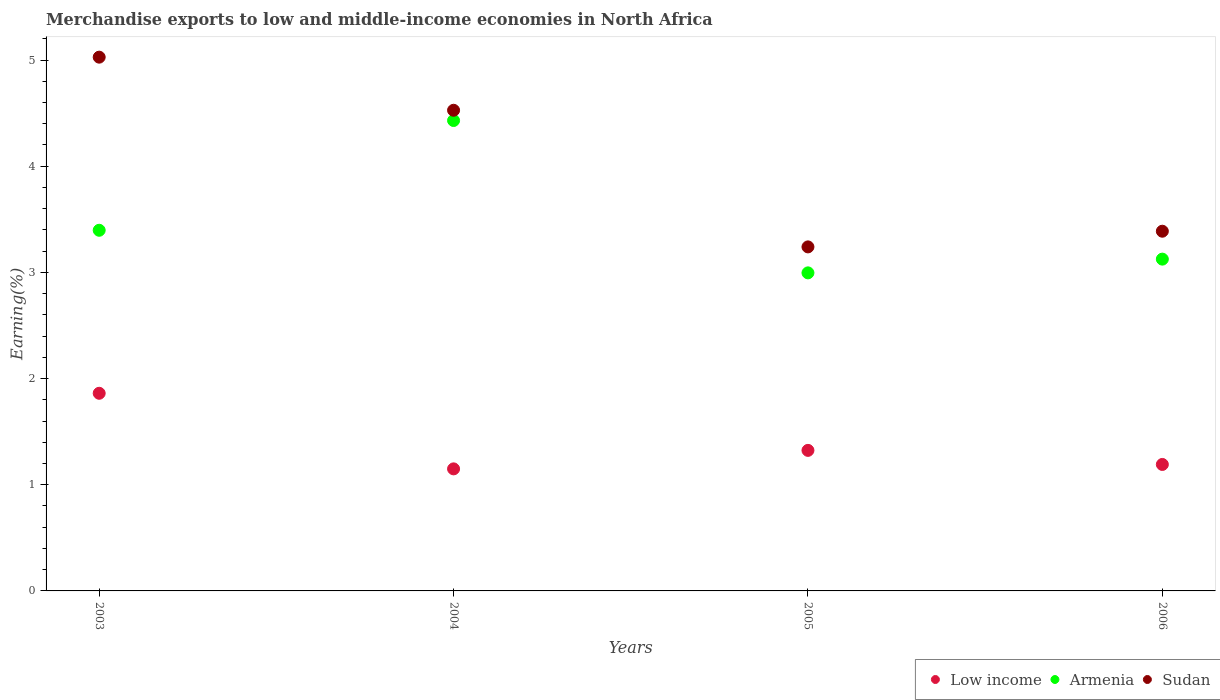Is the number of dotlines equal to the number of legend labels?
Provide a short and direct response. Yes. What is the percentage of amount earned from merchandise exports in Armenia in 2006?
Your answer should be very brief. 3.12. Across all years, what is the maximum percentage of amount earned from merchandise exports in Sudan?
Give a very brief answer. 5.03. Across all years, what is the minimum percentage of amount earned from merchandise exports in Low income?
Keep it short and to the point. 1.15. In which year was the percentage of amount earned from merchandise exports in Sudan maximum?
Offer a very short reply. 2003. In which year was the percentage of amount earned from merchandise exports in Sudan minimum?
Your answer should be compact. 2005. What is the total percentage of amount earned from merchandise exports in Low income in the graph?
Offer a very short reply. 5.53. What is the difference between the percentage of amount earned from merchandise exports in Sudan in 2003 and that in 2005?
Provide a short and direct response. 1.79. What is the difference between the percentage of amount earned from merchandise exports in Sudan in 2006 and the percentage of amount earned from merchandise exports in Armenia in 2005?
Give a very brief answer. 0.39. What is the average percentage of amount earned from merchandise exports in Armenia per year?
Your response must be concise. 3.49. In the year 2003, what is the difference between the percentage of amount earned from merchandise exports in Armenia and percentage of amount earned from merchandise exports in Sudan?
Your answer should be compact. -1.63. In how many years, is the percentage of amount earned from merchandise exports in Low income greater than 3.2 %?
Your answer should be compact. 0. What is the ratio of the percentage of amount earned from merchandise exports in Sudan in 2005 to that in 2006?
Your answer should be compact. 0.96. Is the percentage of amount earned from merchandise exports in Sudan in 2003 less than that in 2006?
Make the answer very short. No. What is the difference between the highest and the second highest percentage of amount earned from merchandise exports in Armenia?
Your answer should be very brief. 1.03. What is the difference between the highest and the lowest percentage of amount earned from merchandise exports in Sudan?
Ensure brevity in your answer.  1.79. In how many years, is the percentage of amount earned from merchandise exports in Armenia greater than the average percentage of amount earned from merchandise exports in Armenia taken over all years?
Keep it short and to the point. 1. Is the sum of the percentage of amount earned from merchandise exports in Low income in 2004 and 2005 greater than the maximum percentage of amount earned from merchandise exports in Armenia across all years?
Your answer should be very brief. No. Is it the case that in every year, the sum of the percentage of amount earned from merchandise exports in Sudan and percentage of amount earned from merchandise exports in Armenia  is greater than the percentage of amount earned from merchandise exports in Low income?
Your response must be concise. Yes. Is the percentage of amount earned from merchandise exports in Low income strictly less than the percentage of amount earned from merchandise exports in Armenia over the years?
Give a very brief answer. Yes. How many dotlines are there?
Provide a short and direct response. 3. Are the values on the major ticks of Y-axis written in scientific E-notation?
Give a very brief answer. No. Does the graph contain grids?
Provide a short and direct response. No. How many legend labels are there?
Your answer should be compact. 3. How are the legend labels stacked?
Give a very brief answer. Horizontal. What is the title of the graph?
Make the answer very short. Merchandise exports to low and middle-income economies in North Africa. Does "Europe(all income levels)" appear as one of the legend labels in the graph?
Make the answer very short. No. What is the label or title of the X-axis?
Your response must be concise. Years. What is the label or title of the Y-axis?
Give a very brief answer. Earning(%). What is the Earning(%) in Low income in 2003?
Offer a very short reply. 1.86. What is the Earning(%) in Armenia in 2003?
Offer a very short reply. 3.4. What is the Earning(%) in Sudan in 2003?
Make the answer very short. 5.03. What is the Earning(%) in Low income in 2004?
Offer a very short reply. 1.15. What is the Earning(%) of Armenia in 2004?
Provide a short and direct response. 4.43. What is the Earning(%) of Sudan in 2004?
Your response must be concise. 4.53. What is the Earning(%) of Low income in 2005?
Give a very brief answer. 1.32. What is the Earning(%) of Armenia in 2005?
Give a very brief answer. 3. What is the Earning(%) of Sudan in 2005?
Make the answer very short. 3.24. What is the Earning(%) in Low income in 2006?
Your answer should be very brief. 1.19. What is the Earning(%) in Armenia in 2006?
Offer a very short reply. 3.12. What is the Earning(%) in Sudan in 2006?
Your response must be concise. 3.39. Across all years, what is the maximum Earning(%) of Low income?
Keep it short and to the point. 1.86. Across all years, what is the maximum Earning(%) of Armenia?
Ensure brevity in your answer.  4.43. Across all years, what is the maximum Earning(%) in Sudan?
Your response must be concise. 5.03. Across all years, what is the minimum Earning(%) of Low income?
Provide a short and direct response. 1.15. Across all years, what is the minimum Earning(%) of Armenia?
Your response must be concise. 3. Across all years, what is the minimum Earning(%) of Sudan?
Ensure brevity in your answer.  3.24. What is the total Earning(%) of Low income in the graph?
Offer a very short reply. 5.53. What is the total Earning(%) of Armenia in the graph?
Your response must be concise. 13.95. What is the total Earning(%) in Sudan in the graph?
Your answer should be very brief. 16.18. What is the difference between the Earning(%) of Low income in 2003 and that in 2004?
Your answer should be compact. 0.71. What is the difference between the Earning(%) of Armenia in 2003 and that in 2004?
Your response must be concise. -1.03. What is the difference between the Earning(%) in Sudan in 2003 and that in 2004?
Offer a terse response. 0.5. What is the difference between the Earning(%) in Low income in 2003 and that in 2005?
Provide a short and direct response. 0.54. What is the difference between the Earning(%) in Armenia in 2003 and that in 2005?
Keep it short and to the point. 0.4. What is the difference between the Earning(%) in Sudan in 2003 and that in 2005?
Give a very brief answer. 1.79. What is the difference between the Earning(%) in Low income in 2003 and that in 2006?
Offer a very short reply. 0.67. What is the difference between the Earning(%) of Armenia in 2003 and that in 2006?
Offer a very short reply. 0.27. What is the difference between the Earning(%) in Sudan in 2003 and that in 2006?
Offer a terse response. 1.64. What is the difference between the Earning(%) of Low income in 2004 and that in 2005?
Your answer should be very brief. -0.17. What is the difference between the Earning(%) in Armenia in 2004 and that in 2005?
Ensure brevity in your answer.  1.43. What is the difference between the Earning(%) in Sudan in 2004 and that in 2005?
Give a very brief answer. 1.29. What is the difference between the Earning(%) in Low income in 2004 and that in 2006?
Offer a terse response. -0.04. What is the difference between the Earning(%) in Armenia in 2004 and that in 2006?
Provide a succinct answer. 1.31. What is the difference between the Earning(%) in Sudan in 2004 and that in 2006?
Provide a succinct answer. 1.14. What is the difference between the Earning(%) in Low income in 2005 and that in 2006?
Give a very brief answer. 0.13. What is the difference between the Earning(%) in Armenia in 2005 and that in 2006?
Give a very brief answer. -0.13. What is the difference between the Earning(%) in Sudan in 2005 and that in 2006?
Provide a succinct answer. -0.15. What is the difference between the Earning(%) of Low income in 2003 and the Earning(%) of Armenia in 2004?
Give a very brief answer. -2.57. What is the difference between the Earning(%) of Low income in 2003 and the Earning(%) of Sudan in 2004?
Give a very brief answer. -2.67. What is the difference between the Earning(%) in Armenia in 2003 and the Earning(%) in Sudan in 2004?
Your response must be concise. -1.13. What is the difference between the Earning(%) in Low income in 2003 and the Earning(%) in Armenia in 2005?
Keep it short and to the point. -1.13. What is the difference between the Earning(%) of Low income in 2003 and the Earning(%) of Sudan in 2005?
Give a very brief answer. -1.38. What is the difference between the Earning(%) of Armenia in 2003 and the Earning(%) of Sudan in 2005?
Make the answer very short. 0.16. What is the difference between the Earning(%) in Low income in 2003 and the Earning(%) in Armenia in 2006?
Make the answer very short. -1.26. What is the difference between the Earning(%) in Low income in 2003 and the Earning(%) in Sudan in 2006?
Your response must be concise. -1.53. What is the difference between the Earning(%) in Armenia in 2003 and the Earning(%) in Sudan in 2006?
Make the answer very short. 0.01. What is the difference between the Earning(%) of Low income in 2004 and the Earning(%) of Armenia in 2005?
Keep it short and to the point. -1.85. What is the difference between the Earning(%) in Low income in 2004 and the Earning(%) in Sudan in 2005?
Give a very brief answer. -2.09. What is the difference between the Earning(%) in Armenia in 2004 and the Earning(%) in Sudan in 2005?
Provide a succinct answer. 1.19. What is the difference between the Earning(%) of Low income in 2004 and the Earning(%) of Armenia in 2006?
Your response must be concise. -1.98. What is the difference between the Earning(%) of Low income in 2004 and the Earning(%) of Sudan in 2006?
Ensure brevity in your answer.  -2.24. What is the difference between the Earning(%) of Armenia in 2004 and the Earning(%) of Sudan in 2006?
Make the answer very short. 1.04. What is the difference between the Earning(%) of Low income in 2005 and the Earning(%) of Armenia in 2006?
Give a very brief answer. -1.8. What is the difference between the Earning(%) in Low income in 2005 and the Earning(%) in Sudan in 2006?
Give a very brief answer. -2.06. What is the difference between the Earning(%) of Armenia in 2005 and the Earning(%) of Sudan in 2006?
Provide a succinct answer. -0.39. What is the average Earning(%) of Low income per year?
Make the answer very short. 1.38. What is the average Earning(%) of Armenia per year?
Your response must be concise. 3.49. What is the average Earning(%) of Sudan per year?
Ensure brevity in your answer.  4.05. In the year 2003, what is the difference between the Earning(%) in Low income and Earning(%) in Armenia?
Your answer should be very brief. -1.54. In the year 2003, what is the difference between the Earning(%) in Low income and Earning(%) in Sudan?
Keep it short and to the point. -3.17. In the year 2003, what is the difference between the Earning(%) of Armenia and Earning(%) of Sudan?
Make the answer very short. -1.63. In the year 2004, what is the difference between the Earning(%) in Low income and Earning(%) in Armenia?
Offer a terse response. -3.28. In the year 2004, what is the difference between the Earning(%) in Low income and Earning(%) in Sudan?
Your answer should be compact. -3.38. In the year 2004, what is the difference between the Earning(%) in Armenia and Earning(%) in Sudan?
Keep it short and to the point. -0.1. In the year 2005, what is the difference between the Earning(%) of Low income and Earning(%) of Armenia?
Provide a short and direct response. -1.67. In the year 2005, what is the difference between the Earning(%) of Low income and Earning(%) of Sudan?
Ensure brevity in your answer.  -1.92. In the year 2005, what is the difference between the Earning(%) of Armenia and Earning(%) of Sudan?
Provide a succinct answer. -0.24. In the year 2006, what is the difference between the Earning(%) of Low income and Earning(%) of Armenia?
Make the answer very short. -1.93. In the year 2006, what is the difference between the Earning(%) of Low income and Earning(%) of Sudan?
Give a very brief answer. -2.2. In the year 2006, what is the difference between the Earning(%) of Armenia and Earning(%) of Sudan?
Ensure brevity in your answer.  -0.26. What is the ratio of the Earning(%) of Low income in 2003 to that in 2004?
Provide a succinct answer. 1.62. What is the ratio of the Earning(%) in Armenia in 2003 to that in 2004?
Provide a succinct answer. 0.77. What is the ratio of the Earning(%) in Sudan in 2003 to that in 2004?
Your answer should be very brief. 1.11. What is the ratio of the Earning(%) of Low income in 2003 to that in 2005?
Make the answer very short. 1.41. What is the ratio of the Earning(%) in Armenia in 2003 to that in 2005?
Provide a short and direct response. 1.13. What is the ratio of the Earning(%) in Sudan in 2003 to that in 2005?
Your answer should be compact. 1.55. What is the ratio of the Earning(%) of Low income in 2003 to that in 2006?
Provide a succinct answer. 1.56. What is the ratio of the Earning(%) in Armenia in 2003 to that in 2006?
Ensure brevity in your answer.  1.09. What is the ratio of the Earning(%) of Sudan in 2003 to that in 2006?
Provide a succinct answer. 1.48. What is the ratio of the Earning(%) in Low income in 2004 to that in 2005?
Your answer should be compact. 0.87. What is the ratio of the Earning(%) in Armenia in 2004 to that in 2005?
Offer a very short reply. 1.48. What is the ratio of the Earning(%) of Sudan in 2004 to that in 2005?
Keep it short and to the point. 1.4. What is the ratio of the Earning(%) of Low income in 2004 to that in 2006?
Your answer should be very brief. 0.97. What is the ratio of the Earning(%) of Armenia in 2004 to that in 2006?
Offer a terse response. 1.42. What is the ratio of the Earning(%) of Sudan in 2004 to that in 2006?
Provide a succinct answer. 1.34. What is the ratio of the Earning(%) in Low income in 2005 to that in 2006?
Keep it short and to the point. 1.11. What is the ratio of the Earning(%) in Armenia in 2005 to that in 2006?
Your answer should be compact. 0.96. What is the ratio of the Earning(%) in Sudan in 2005 to that in 2006?
Your response must be concise. 0.96. What is the difference between the highest and the second highest Earning(%) of Low income?
Make the answer very short. 0.54. What is the difference between the highest and the second highest Earning(%) in Armenia?
Offer a terse response. 1.03. What is the difference between the highest and the second highest Earning(%) of Sudan?
Your answer should be compact. 0.5. What is the difference between the highest and the lowest Earning(%) of Low income?
Offer a very short reply. 0.71. What is the difference between the highest and the lowest Earning(%) in Armenia?
Give a very brief answer. 1.43. What is the difference between the highest and the lowest Earning(%) in Sudan?
Ensure brevity in your answer.  1.79. 